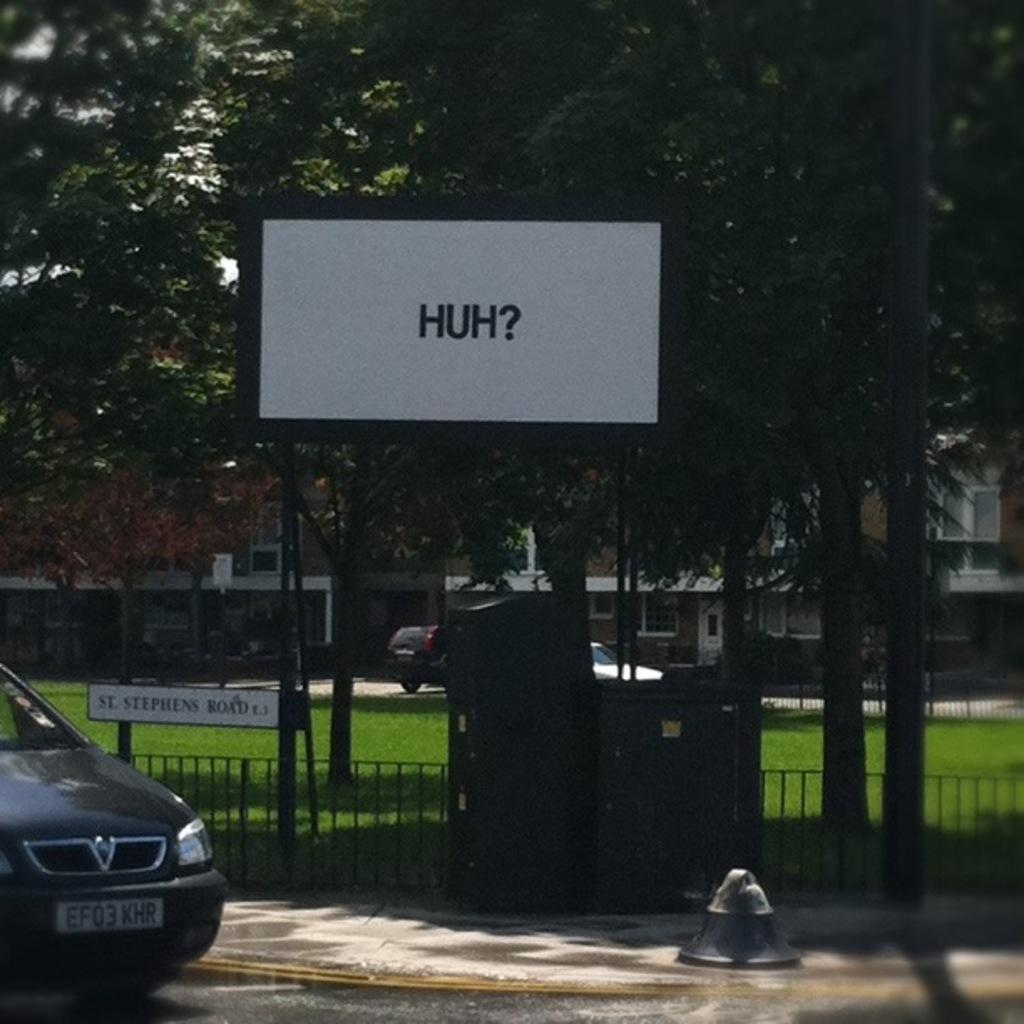What can be seen in the left corner of the image? There is a car in the left corner of the image. What is located beside the car? There is a board with writing beside the car. What type of environment is visible in the background of the image? There are trees and buildings in the background of the image. How many vehicles can be seen in the background of the image? There are two vehicles in the background of the image. What type of cake is being served at the event in the image? There is no event or cake present in the image; it features a car, a board with writing, and a background with trees and buildings. 